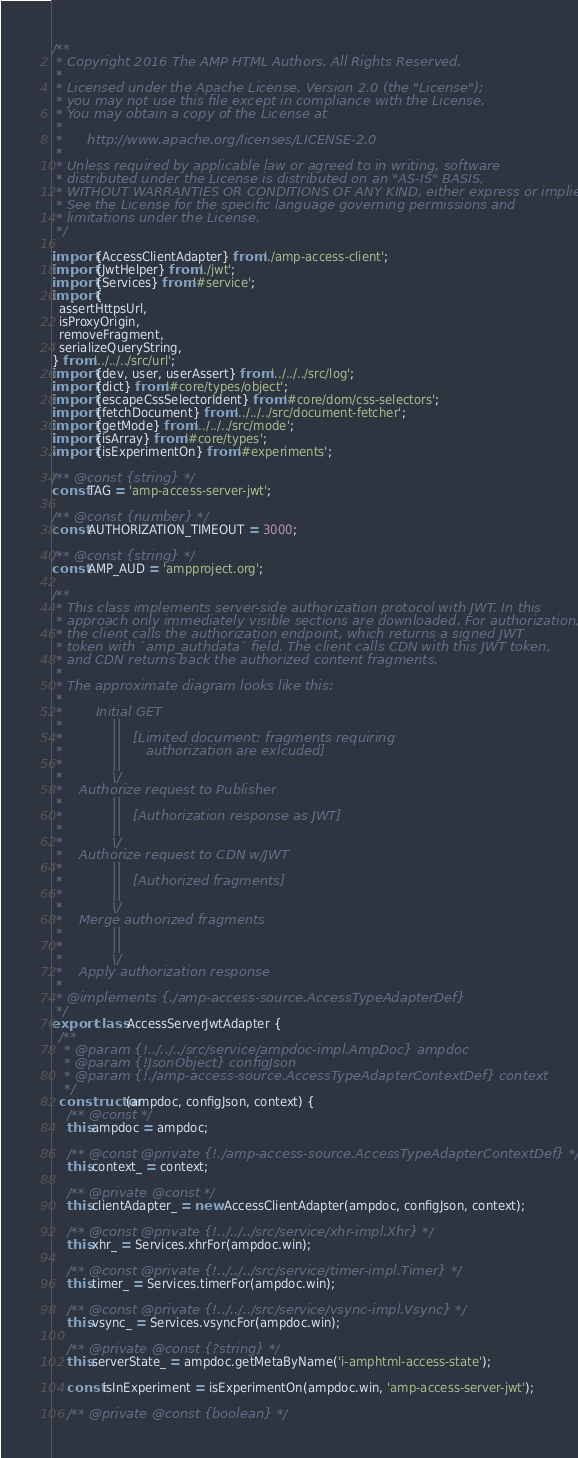Convert code to text. <code><loc_0><loc_0><loc_500><loc_500><_JavaScript_>/**
 * Copyright 2016 The AMP HTML Authors. All Rights Reserved.
 *
 * Licensed under the Apache License, Version 2.0 (the "License");
 * you may not use this file except in compliance with the License.
 * You may obtain a copy of the License at
 *
 *      http://www.apache.org/licenses/LICENSE-2.0
 *
 * Unless required by applicable law or agreed to in writing, software
 * distributed under the License is distributed on an "AS-IS" BASIS,
 * WITHOUT WARRANTIES OR CONDITIONS OF ANY KIND, either express or implied.
 * See the License for the specific language governing permissions and
 * limitations under the License.
 */

import {AccessClientAdapter} from './amp-access-client';
import {JwtHelper} from './jwt';
import {Services} from '#service';
import {
  assertHttpsUrl,
  isProxyOrigin,
  removeFragment,
  serializeQueryString,
} from '../../../src/url';
import {dev, user, userAssert} from '../../../src/log';
import {dict} from '#core/types/object';
import {escapeCssSelectorIdent} from '#core/dom/css-selectors';
import {fetchDocument} from '../../../src/document-fetcher';
import {getMode} from '../../../src/mode';
import {isArray} from '#core/types';
import {isExperimentOn} from '#experiments';

/** @const {string} */
const TAG = 'amp-access-server-jwt';

/** @const {number} */
const AUTHORIZATION_TIMEOUT = 3000;

/** @const {string} */
const AMP_AUD = 'ampproject.org';

/**
 * This class implements server-side authorization protocol with JWT. In this
 * approach only immediately visible sections are downloaded. For authorization,
 * the client calls the authorization endpoint, which returns a signed JWT
 * token with `amp_authdata` field. The client calls CDN with this JWT token,
 * and CDN returns back the authorized content fragments.
 *
 * The approximate diagram looks like this:
 *
 *        Initial GET
 *            ||
 *            ||   [Limited document: fragments requiring
 *            ||      authorization are exlcuded]
 *            ||
 *            \/
 *    Authorize request to Publisher
 *            ||
 *            ||   [Authorization response as JWT]
 *            ||
 *            \/
 *    Authorize request to CDN w/JWT
 *            ||
 *            ||   [Authorized fragments]
 *            ||
 *            \/
 *    Merge authorized fragments
 *            ||
 *            ||
 *            \/
 *    Apply authorization response
 *
 * @implements {./amp-access-source.AccessTypeAdapterDef}
 */
export class AccessServerJwtAdapter {
  /**
   * @param {!../../../src/service/ampdoc-impl.AmpDoc} ampdoc
   * @param {!JsonObject} configJson
   * @param {!./amp-access-source.AccessTypeAdapterContextDef} context
   */
  constructor(ampdoc, configJson, context) {
    /** @const */
    this.ampdoc = ampdoc;

    /** @const @private {!./amp-access-source.AccessTypeAdapterContextDef} */
    this.context_ = context;

    /** @private @const */
    this.clientAdapter_ = new AccessClientAdapter(ampdoc, configJson, context);

    /** @const @private {!../../../src/service/xhr-impl.Xhr} */
    this.xhr_ = Services.xhrFor(ampdoc.win);

    /** @const @private {!../../../src/service/timer-impl.Timer} */
    this.timer_ = Services.timerFor(ampdoc.win);

    /** @const @private {!../../../src/service/vsync-impl.Vsync} */
    this.vsync_ = Services.vsyncFor(ampdoc.win);

    /** @private @const {?string} */
    this.serverState_ = ampdoc.getMetaByName('i-amphtml-access-state');

    const isInExperiment = isExperimentOn(ampdoc.win, 'amp-access-server-jwt');

    /** @private @const {boolean} */</code> 